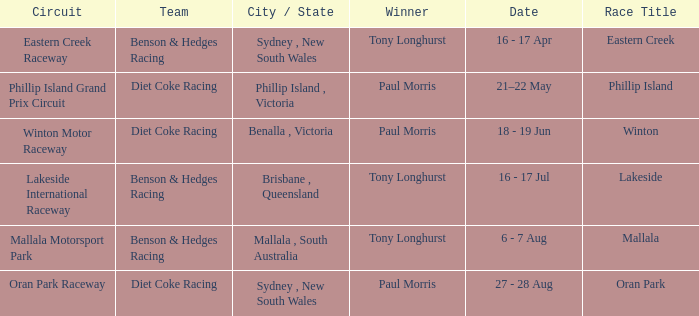Which driver won the Phillip Island Grand Prix Circuit? Paul Morris. 